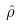Convert formula to latex. <formula><loc_0><loc_0><loc_500><loc_500>\hat { \rho }</formula> 